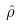Convert formula to latex. <formula><loc_0><loc_0><loc_500><loc_500>\hat { \rho }</formula> 